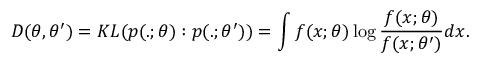Convert formula to latex. <formula><loc_0><loc_0><loc_500><loc_500>D ( \theta , \theta ^ { \prime } ) = K L ( p ( . ; \theta ) \colon p ( . ; \theta ^ { \prime } ) ) = \int f ( x ; \theta ) \log { \frac { f ( x ; \theta ) } { f ( x ; \theta ^ { \prime } ) } } d x .</formula> 